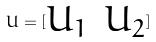Convert formula to latex. <formula><loc_0><loc_0><loc_500><loc_500>U = [ \begin{matrix} U _ { 1 } & U _ { 2 } \end{matrix} ]</formula> 